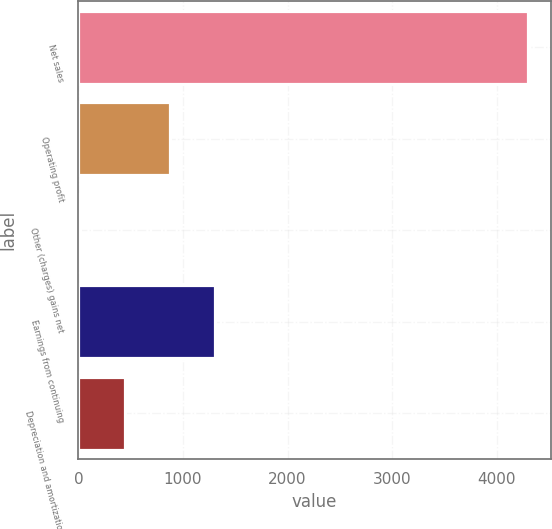Convert chart to OTSL. <chart><loc_0><loc_0><loc_500><loc_500><bar_chart><fcel>Net sales<fcel>Operating profit<fcel>Other (charges) gains net<fcel>Earnings from continuing<fcel>Depreciation and amortization<nl><fcel>4299<fcel>874.2<fcel>18<fcel>1302.3<fcel>446.1<nl></chart> 